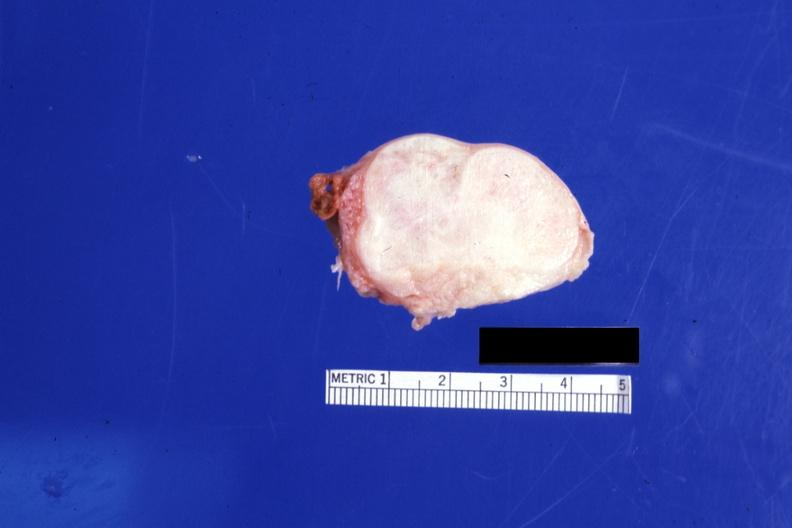how many cm does this image show cut surface lesion 76yobf?
Answer the question using a single word or phrase. 4 